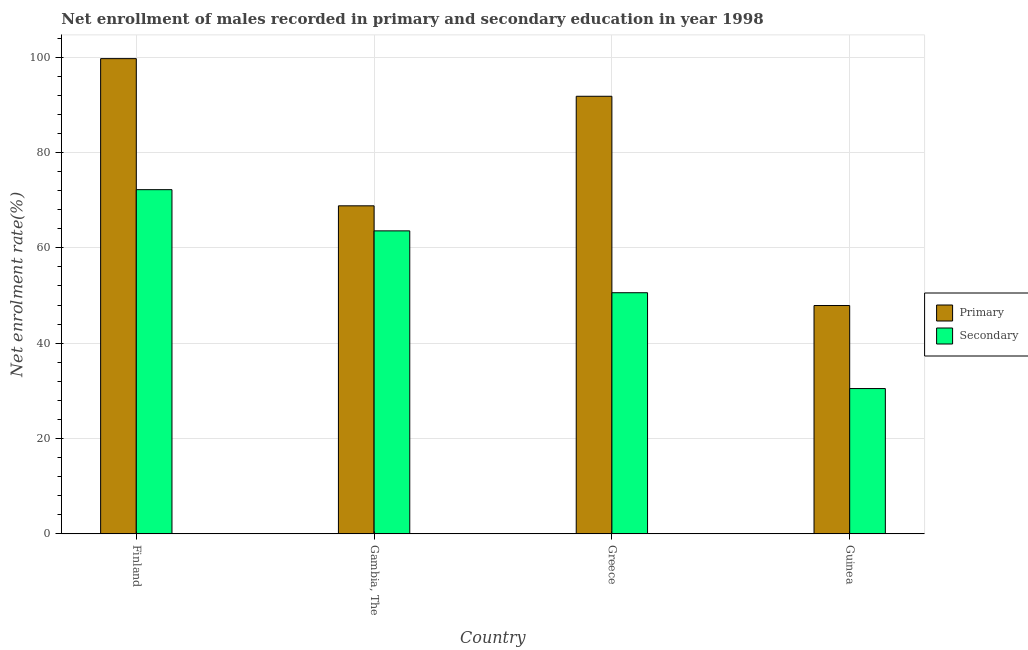How many groups of bars are there?
Provide a succinct answer. 4. How many bars are there on the 2nd tick from the left?
Provide a short and direct response. 2. What is the label of the 2nd group of bars from the left?
Your answer should be very brief. Gambia, The. What is the enrollment rate in primary education in Finland?
Offer a terse response. 99.68. Across all countries, what is the maximum enrollment rate in primary education?
Offer a very short reply. 99.68. Across all countries, what is the minimum enrollment rate in primary education?
Keep it short and to the point. 47.89. In which country was the enrollment rate in primary education minimum?
Keep it short and to the point. Guinea. What is the total enrollment rate in secondary education in the graph?
Ensure brevity in your answer.  216.8. What is the difference between the enrollment rate in primary education in Finland and that in Gambia, The?
Provide a succinct answer. 30.87. What is the difference between the enrollment rate in primary education in Gambia, The and the enrollment rate in secondary education in Finland?
Offer a terse response. -3.39. What is the average enrollment rate in secondary education per country?
Your answer should be very brief. 54.2. What is the difference between the enrollment rate in primary education and enrollment rate in secondary education in Gambia, The?
Keep it short and to the point. 5.25. What is the ratio of the enrollment rate in secondary education in Gambia, The to that in Greece?
Offer a very short reply. 1.26. Is the difference between the enrollment rate in primary education in Finland and Gambia, The greater than the difference between the enrollment rate in secondary education in Finland and Gambia, The?
Your response must be concise. Yes. What is the difference between the highest and the second highest enrollment rate in primary education?
Make the answer very short. 7.89. What is the difference between the highest and the lowest enrollment rate in secondary education?
Your response must be concise. 41.72. Is the sum of the enrollment rate in primary education in Finland and Greece greater than the maximum enrollment rate in secondary education across all countries?
Offer a terse response. Yes. What does the 1st bar from the left in Greece represents?
Your response must be concise. Primary. What does the 2nd bar from the right in Finland represents?
Keep it short and to the point. Primary. How many bars are there?
Keep it short and to the point. 8. Are all the bars in the graph horizontal?
Provide a short and direct response. No. How many countries are there in the graph?
Provide a succinct answer. 4. What is the difference between two consecutive major ticks on the Y-axis?
Your answer should be compact. 20. Does the graph contain any zero values?
Provide a short and direct response. No. How many legend labels are there?
Offer a terse response. 2. How are the legend labels stacked?
Your answer should be very brief. Vertical. What is the title of the graph?
Provide a short and direct response. Net enrollment of males recorded in primary and secondary education in year 1998. What is the label or title of the Y-axis?
Your answer should be very brief. Net enrolment rate(%). What is the Net enrolment rate(%) in Primary in Finland?
Provide a short and direct response. 99.68. What is the Net enrolment rate(%) of Secondary in Finland?
Ensure brevity in your answer.  72.19. What is the Net enrolment rate(%) of Primary in Gambia, The?
Your answer should be very brief. 68.81. What is the Net enrolment rate(%) of Secondary in Gambia, The?
Provide a short and direct response. 63.55. What is the Net enrolment rate(%) in Primary in Greece?
Give a very brief answer. 91.78. What is the Net enrolment rate(%) in Secondary in Greece?
Your response must be concise. 50.58. What is the Net enrolment rate(%) of Primary in Guinea?
Give a very brief answer. 47.89. What is the Net enrolment rate(%) in Secondary in Guinea?
Ensure brevity in your answer.  30.48. Across all countries, what is the maximum Net enrolment rate(%) in Primary?
Your response must be concise. 99.68. Across all countries, what is the maximum Net enrolment rate(%) in Secondary?
Your answer should be compact. 72.19. Across all countries, what is the minimum Net enrolment rate(%) in Primary?
Offer a terse response. 47.89. Across all countries, what is the minimum Net enrolment rate(%) of Secondary?
Make the answer very short. 30.48. What is the total Net enrolment rate(%) in Primary in the graph?
Offer a terse response. 308.16. What is the total Net enrolment rate(%) in Secondary in the graph?
Your response must be concise. 216.8. What is the difference between the Net enrolment rate(%) in Primary in Finland and that in Gambia, The?
Your response must be concise. 30.87. What is the difference between the Net enrolment rate(%) of Secondary in Finland and that in Gambia, The?
Your answer should be very brief. 8.64. What is the difference between the Net enrolment rate(%) in Primary in Finland and that in Greece?
Your answer should be very brief. 7.89. What is the difference between the Net enrolment rate(%) in Secondary in Finland and that in Greece?
Make the answer very short. 21.62. What is the difference between the Net enrolment rate(%) of Primary in Finland and that in Guinea?
Your answer should be very brief. 51.78. What is the difference between the Net enrolment rate(%) in Secondary in Finland and that in Guinea?
Keep it short and to the point. 41.72. What is the difference between the Net enrolment rate(%) in Primary in Gambia, The and that in Greece?
Give a very brief answer. -22.98. What is the difference between the Net enrolment rate(%) of Secondary in Gambia, The and that in Greece?
Keep it short and to the point. 12.98. What is the difference between the Net enrolment rate(%) in Primary in Gambia, The and that in Guinea?
Keep it short and to the point. 20.91. What is the difference between the Net enrolment rate(%) of Secondary in Gambia, The and that in Guinea?
Keep it short and to the point. 33.08. What is the difference between the Net enrolment rate(%) of Primary in Greece and that in Guinea?
Offer a very short reply. 43.89. What is the difference between the Net enrolment rate(%) in Secondary in Greece and that in Guinea?
Provide a short and direct response. 20.1. What is the difference between the Net enrolment rate(%) in Primary in Finland and the Net enrolment rate(%) in Secondary in Gambia, The?
Provide a succinct answer. 36.12. What is the difference between the Net enrolment rate(%) of Primary in Finland and the Net enrolment rate(%) of Secondary in Greece?
Ensure brevity in your answer.  49.1. What is the difference between the Net enrolment rate(%) of Primary in Finland and the Net enrolment rate(%) of Secondary in Guinea?
Your answer should be very brief. 69.2. What is the difference between the Net enrolment rate(%) of Primary in Gambia, The and the Net enrolment rate(%) of Secondary in Greece?
Offer a very short reply. 18.23. What is the difference between the Net enrolment rate(%) in Primary in Gambia, The and the Net enrolment rate(%) in Secondary in Guinea?
Ensure brevity in your answer.  38.33. What is the difference between the Net enrolment rate(%) in Primary in Greece and the Net enrolment rate(%) in Secondary in Guinea?
Your response must be concise. 61.31. What is the average Net enrolment rate(%) in Primary per country?
Give a very brief answer. 77.04. What is the average Net enrolment rate(%) of Secondary per country?
Provide a short and direct response. 54.2. What is the difference between the Net enrolment rate(%) in Primary and Net enrolment rate(%) in Secondary in Finland?
Offer a terse response. 27.48. What is the difference between the Net enrolment rate(%) of Primary and Net enrolment rate(%) of Secondary in Gambia, The?
Ensure brevity in your answer.  5.25. What is the difference between the Net enrolment rate(%) of Primary and Net enrolment rate(%) of Secondary in Greece?
Ensure brevity in your answer.  41.21. What is the difference between the Net enrolment rate(%) of Primary and Net enrolment rate(%) of Secondary in Guinea?
Give a very brief answer. 17.42. What is the ratio of the Net enrolment rate(%) of Primary in Finland to that in Gambia, The?
Offer a terse response. 1.45. What is the ratio of the Net enrolment rate(%) of Secondary in Finland to that in Gambia, The?
Your answer should be very brief. 1.14. What is the ratio of the Net enrolment rate(%) in Primary in Finland to that in Greece?
Keep it short and to the point. 1.09. What is the ratio of the Net enrolment rate(%) of Secondary in Finland to that in Greece?
Provide a short and direct response. 1.43. What is the ratio of the Net enrolment rate(%) in Primary in Finland to that in Guinea?
Your response must be concise. 2.08. What is the ratio of the Net enrolment rate(%) of Secondary in Finland to that in Guinea?
Give a very brief answer. 2.37. What is the ratio of the Net enrolment rate(%) of Primary in Gambia, The to that in Greece?
Offer a terse response. 0.75. What is the ratio of the Net enrolment rate(%) in Secondary in Gambia, The to that in Greece?
Keep it short and to the point. 1.26. What is the ratio of the Net enrolment rate(%) in Primary in Gambia, The to that in Guinea?
Ensure brevity in your answer.  1.44. What is the ratio of the Net enrolment rate(%) of Secondary in Gambia, The to that in Guinea?
Provide a short and direct response. 2.09. What is the ratio of the Net enrolment rate(%) of Primary in Greece to that in Guinea?
Ensure brevity in your answer.  1.92. What is the ratio of the Net enrolment rate(%) of Secondary in Greece to that in Guinea?
Make the answer very short. 1.66. What is the difference between the highest and the second highest Net enrolment rate(%) in Primary?
Your response must be concise. 7.89. What is the difference between the highest and the second highest Net enrolment rate(%) in Secondary?
Keep it short and to the point. 8.64. What is the difference between the highest and the lowest Net enrolment rate(%) in Primary?
Keep it short and to the point. 51.78. What is the difference between the highest and the lowest Net enrolment rate(%) in Secondary?
Give a very brief answer. 41.72. 